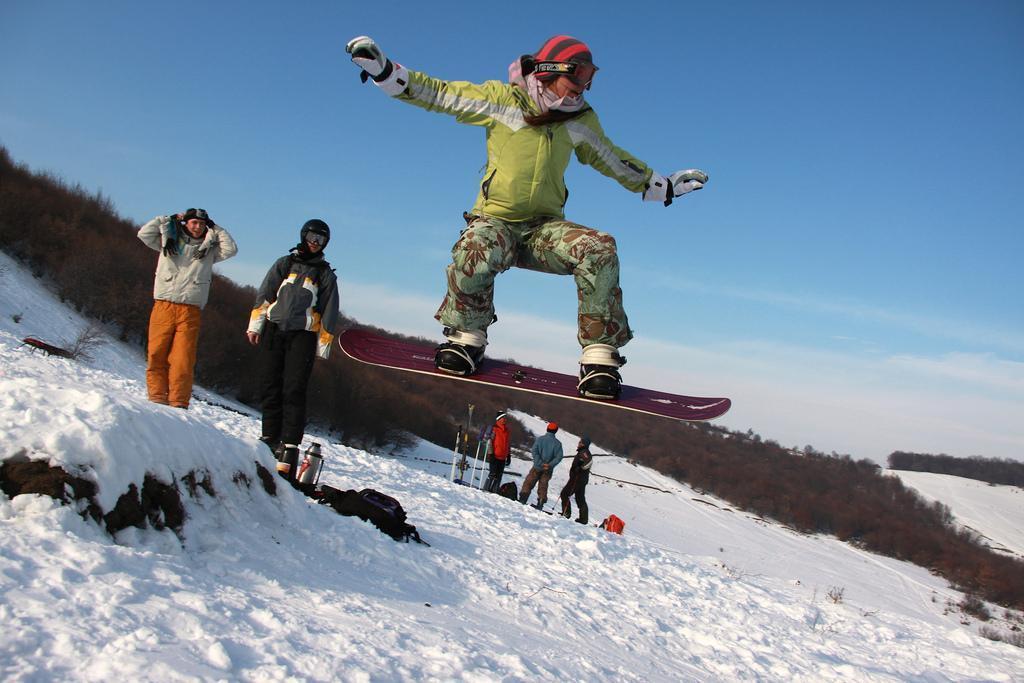How many people are in the air?
Give a very brief answer. 1. 